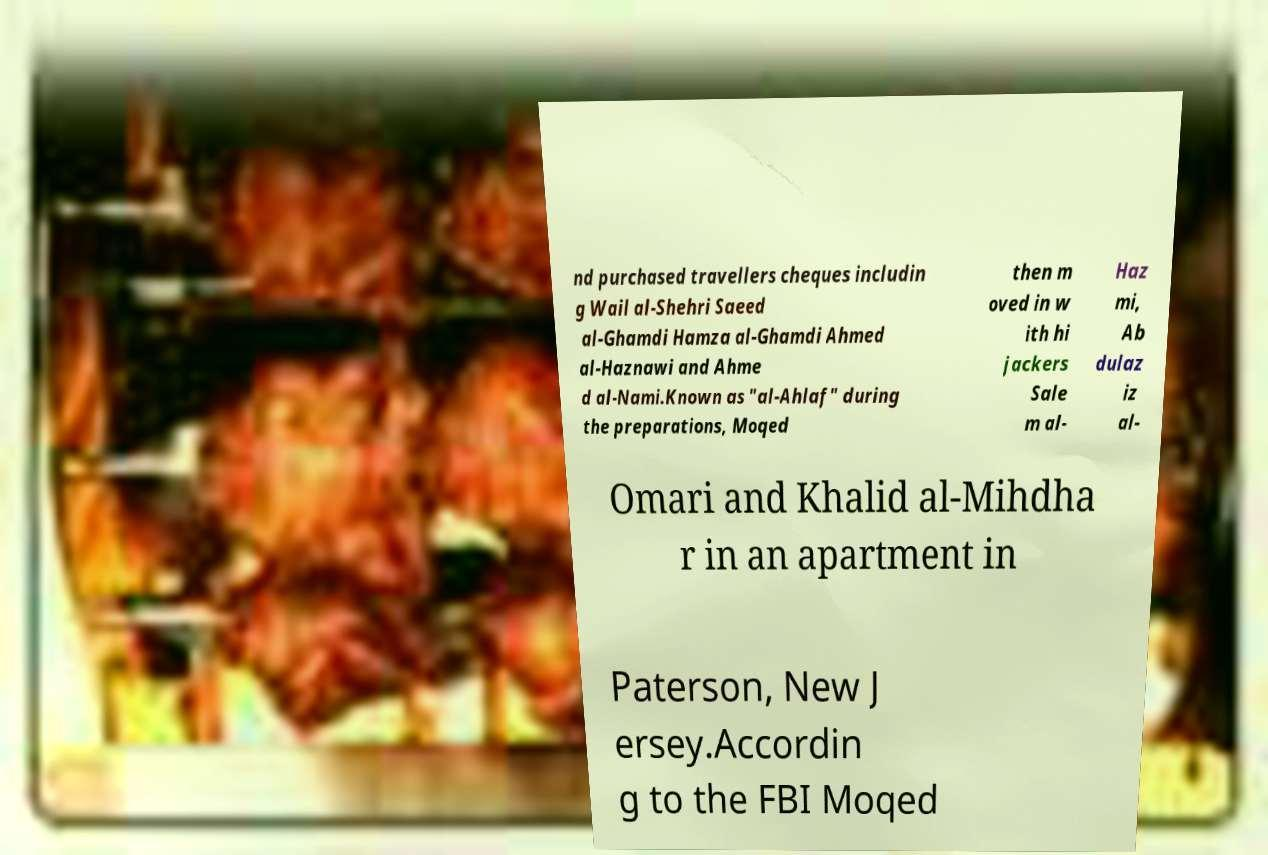What messages or text are displayed in this image? I need them in a readable, typed format. nd purchased travellers cheques includin g Wail al-Shehri Saeed al-Ghamdi Hamza al-Ghamdi Ahmed al-Haznawi and Ahme d al-Nami.Known as "al-Ahlaf" during the preparations, Moqed then m oved in w ith hi jackers Sale m al- Haz mi, Ab dulaz iz al- Omari and Khalid al-Mihdha r in an apartment in Paterson, New J ersey.Accordin g to the FBI Moqed 